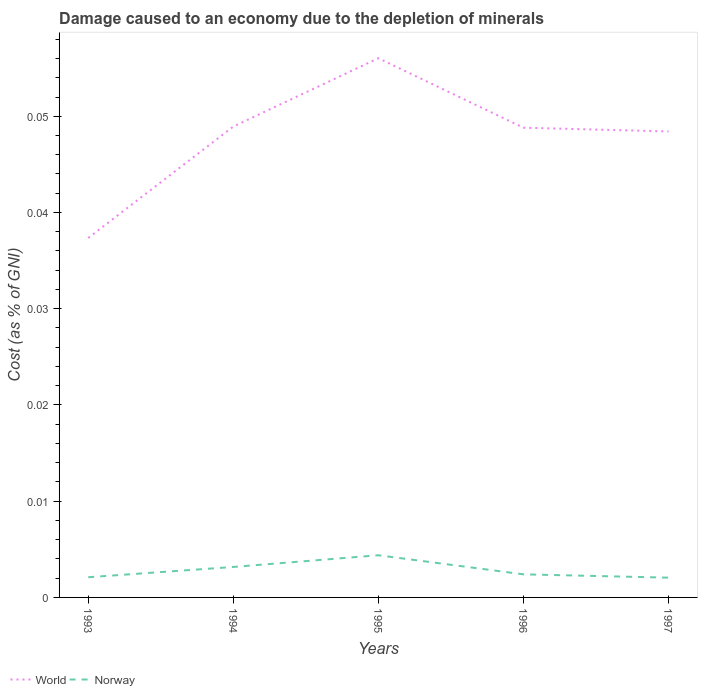How many different coloured lines are there?
Your answer should be compact. 2. Across all years, what is the maximum cost of damage caused due to the depletion of minerals in World?
Provide a short and direct response. 0.04. What is the total cost of damage caused due to the depletion of minerals in Norway in the graph?
Offer a terse response. 0. What is the difference between the highest and the second highest cost of damage caused due to the depletion of minerals in World?
Offer a very short reply. 0.02. Is the cost of damage caused due to the depletion of minerals in World strictly greater than the cost of damage caused due to the depletion of minerals in Norway over the years?
Make the answer very short. No. How many years are there in the graph?
Give a very brief answer. 5. What is the difference between two consecutive major ticks on the Y-axis?
Offer a terse response. 0.01. Are the values on the major ticks of Y-axis written in scientific E-notation?
Ensure brevity in your answer.  No. Does the graph contain any zero values?
Offer a very short reply. No. Does the graph contain grids?
Offer a terse response. No. What is the title of the graph?
Provide a short and direct response. Damage caused to an economy due to the depletion of minerals. Does "Chad" appear as one of the legend labels in the graph?
Offer a very short reply. No. What is the label or title of the X-axis?
Provide a succinct answer. Years. What is the label or title of the Y-axis?
Your response must be concise. Cost (as % of GNI). What is the Cost (as % of GNI) in World in 1993?
Your answer should be very brief. 0.04. What is the Cost (as % of GNI) of Norway in 1993?
Make the answer very short. 0. What is the Cost (as % of GNI) of World in 1994?
Provide a succinct answer. 0.05. What is the Cost (as % of GNI) in Norway in 1994?
Make the answer very short. 0. What is the Cost (as % of GNI) of World in 1995?
Make the answer very short. 0.06. What is the Cost (as % of GNI) of Norway in 1995?
Keep it short and to the point. 0. What is the Cost (as % of GNI) of World in 1996?
Provide a short and direct response. 0.05. What is the Cost (as % of GNI) in Norway in 1996?
Provide a succinct answer. 0. What is the Cost (as % of GNI) of World in 1997?
Provide a short and direct response. 0.05. What is the Cost (as % of GNI) in Norway in 1997?
Ensure brevity in your answer.  0. Across all years, what is the maximum Cost (as % of GNI) of World?
Offer a terse response. 0.06. Across all years, what is the maximum Cost (as % of GNI) of Norway?
Offer a very short reply. 0. Across all years, what is the minimum Cost (as % of GNI) in World?
Your answer should be compact. 0.04. Across all years, what is the minimum Cost (as % of GNI) of Norway?
Your answer should be very brief. 0. What is the total Cost (as % of GNI) of World in the graph?
Offer a terse response. 0.24. What is the total Cost (as % of GNI) in Norway in the graph?
Give a very brief answer. 0.01. What is the difference between the Cost (as % of GNI) in World in 1993 and that in 1994?
Your answer should be compact. -0.01. What is the difference between the Cost (as % of GNI) in Norway in 1993 and that in 1994?
Offer a very short reply. -0. What is the difference between the Cost (as % of GNI) in World in 1993 and that in 1995?
Offer a terse response. -0.02. What is the difference between the Cost (as % of GNI) in Norway in 1993 and that in 1995?
Your answer should be compact. -0. What is the difference between the Cost (as % of GNI) in World in 1993 and that in 1996?
Your response must be concise. -0.01. What is the difference between the Cost (as % of GNI) of Norway in 1993 and that in 1996?
Your response must be concise. -0. What is the difference between the Cost (as % of GNI) in World in 1993 and that in 1997?
Your response must be concise. -0.01. What is the difference between the Cost (as % of GNI) of Norway in 1993 and that in 1997?
Make the answer very short. 0. What is the difference between the Cost (as % of GNI) of World in 1994 and that in 1995?
Provide a succinct answer. -0.01. What is the difference between the Cost (as % of GNI) in Norway in 1994 and that in 1995?
Give a very brief answer. -0. What is the difference between the Cost (as % of GNI) of Norway in 1994 and that in 1996?
Provide a succinct answer. 0. What is the difference between the Cost (as % of GNI) in Norway in 1994 and that in 1997?
Give a very brief answer. 0. What is the difference between the Cost (as % of GNI) in World in 1995 and that in 1996?
Your response must be concise. 0.01. What is the difference between the Cost (as % of GNI) of Norway in 1995 and that in 1996?
Offer a terse response. 0. What is the difference between the Cost (as % of GNI) of World in 1995 and that in 1997?
Give a very brief answer. 0.01. What is the difference between the Cost (as % of GNI) in Norway in 1995 and that in 1997?
Your answer should be compact. 0. What is the difference between the Cost (as % of GNI) of World in 1993 and the Cost (as % of GNI) of Norway in 1994?
Offer a terse response. 0.03. What is the difference between the Cost (as % of GNI) in World in 1993 and the Cost (as % of GNI) in Norway in 1995?
Give a very brief answer. 0.03. What is the difference between the Cost (as % of GNI) of World in 1993 and the Cost (as % of GNI) of Norway in 1996?
Ensure brevity in your answer.  0.04. What is the difference between the Cost (as % of GNI) in World in 1993 and the Cost (as % of GNI) in Norway in 1997?
Your answer should be compact. 0.04. What is the difference between the Cost (as % of GNI) in World in 1994 and the Cost (as % of GNI) in Norway in 1995?
Ensure brevity in your answer.  0.04. What is the difference between the Cost (as % of GNI) in World in 1994 and the Cost (as % of GNI) in Norway in 1996?
Provide a short and direct response. 0.05. What is the difference between the Cost (as % of GNI) of World in 1994 and the Cost (as % of GNI) of Norway in 1997?
Your response must be concise. 0.05. What is the difference between the Cost (as % of GNI) in World in 1995 and the Cost (as % of GNI) in Norway in 1996?
Make the answer very short. 0.05. What is the difference between the Cost (as % of GNI) of World in 1995 and the Cost (as % of GNI) of Norway in 1997?
Keep it short and to the point. 0.05. What is the difference between the Cost (as % of GNI) in World in 1996 and the Cost (as % of GNI) in Norway in 1997?
Your answer should be compact. 0.05. What is the average Cost (as % of GNI) in World per year?
Make the answer very short. 0.05. What is the average Cost (as % of GNI) in Norway per year?
Your answer should be very brief. 0. In the year 1993, what is the difference between the Cost (as % of GNI) in World and Cost (as % of GNI) in Norway?
Your response must be concise. 0.04. In the year 1994, what is the difference between the Cost (as % of GNI) of World and Cost (as % of GNI) of Norway?
Ensure brevity in your answer.  0.05. In the year 1995, what is the difference between the Cost (as % of GNI) in World and Cost (as % of GNI) in Norway?
Provide a succinct answer. 0.05. In the year 1996, what is the difference between the Cost (as % of GNI) of World and Cost (as % of GNI) of Norway?
Offer a very short reply. 0.05. In the year 1997, what is the difference between the Cost (as % of GNI) of World and Cost (as % of GNI) of Norway?
Your answer should be compact. 0.05. What is the ratio of the Cost (as % of GNI) of World in 1993 to that in 1994?
Provide a succinct answer. 0.76. What is the ratio of the Cost (as % of GNI) of Norway in 1993 to that in 1994?
Your answer should be compact. 0.66. What is the ratio of the Cost (as % of GNI) in World in 1993 to that in 1995?
Provide a short and direct response. 0.67. What is the ratio of the Cost (as % of GNI) of Norway in 1993 to that in 1995?
Offer a very short reply. 0.48. What is the ratio of the Cost (as % of GNI) in World in 1993 to that in 1996?
Offer a terse response. 0.77. What is the ratio of the Cost (as % of GNI) of Norway in 1993 to that in 1996?
Give a very brief answer. 0.87. What is the ratio of the Cost (as % of GNI) in World in 1993 to that in 1997?
Your response must be concise. 0.77. What is the ratio of the Cost (as % of GNI) of Norway in 1993 to that in 1997?
Keep it short and to the point. 1.02. What is the ratio of the Cost (as % of GNI) of World in 1994 to that in 1995?
Your answer should be compact. 0.87. What is the ratio of the Cost (as % of GNI) in Norway in 1994 to that in 1995?
Keep it short and to the point. 0.72. What is the ratio of the Cost (as % of GNI) in Norway in 1994 to that in 1996?
Your answer should be compact. 1.32. What is the ratio of the Cost (as % of GNI) in World in 1994 to that in 1997?
Offer a terse response. 1.01. What is the ratio of the Cost (as % of GNI) of Norway in 1994 to that in 1997?
Your answer should be compact. 1.54. What is the ratio of the Cost (as % of GNI) in World in 1995 to that in 1996?
Ensure brevity in your answer.  1.15. What is the ratio of the Cost (as % of GNI) in Norway in 1995 to that in 1996?
Your response must be concise. 1.83. What is the ratio of the Cost (as % of GNI) of World in 1995 to that in 1997?
Provide a succinct answer. 1.16. What is the ratio of the Cost (as % of GNI) of Norway in 1995 to that in 1997?
Give a very brief answer. 2.13. What is the ratio of the Cost (as % of GNI) in World in 1996 to that in 1997?
Your response must be concise. 1.01. What is the ratio of the Cost (as % of GNI) of Norway in 1996 to that in 1997?
Your answer should be very brief. 1.17. What is the difference between the highest and the second highest Cost (as % of GNI) of World?
Ensure brevity in your answer.  0.01. What is the difference between the highest and the second highest Cost (as % of GNI) in Norway?
Your response must be concise. 0. What is the difference between the highest and the lowest Cost (as % of GNI) in World?
Provide a succinct answer. 0.02. What is the difference between the highest and the lowest Cost (as % of GNI) of Norway?
Offer a very short reply. 0. 